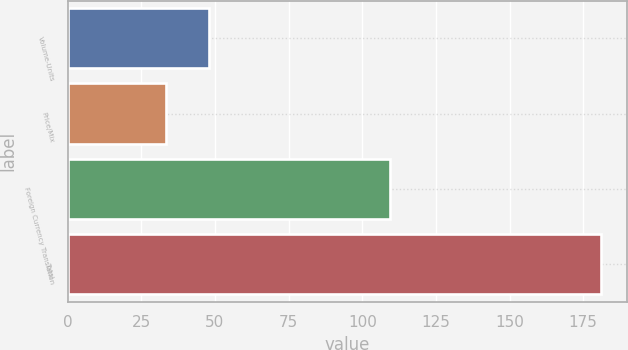Convert chart to OTSL. <chart><loc_0><loc_0><loc_500><loc_500><bar_chart><fcel>Volume-Units<fcel>Price/Mix<fcel>Foreign Currency Translation<fcel>Total<nl><fcel>48.06<fcel>33.3<fcel>109.5<fcel>180.9<nl></chart> 